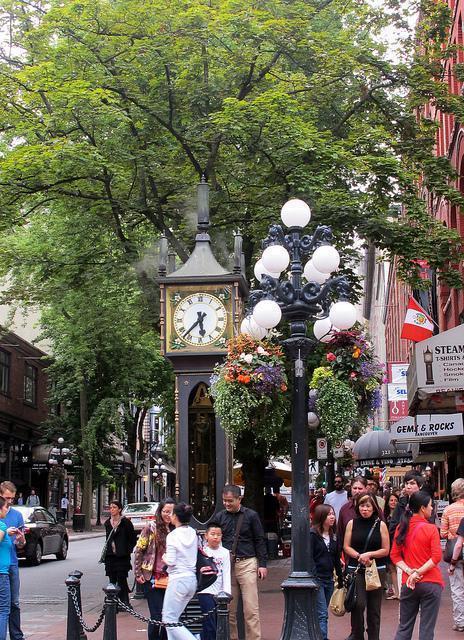What is coming out of the clock?
Make your selection and explain in format: 'Answer: answer
Rationale: rationale.'
Options: Vapor, water, steam, smoke. Answer: steam.
Rationale: There is no steam coming out of the clock but it looks like it due to the location near the trees. 